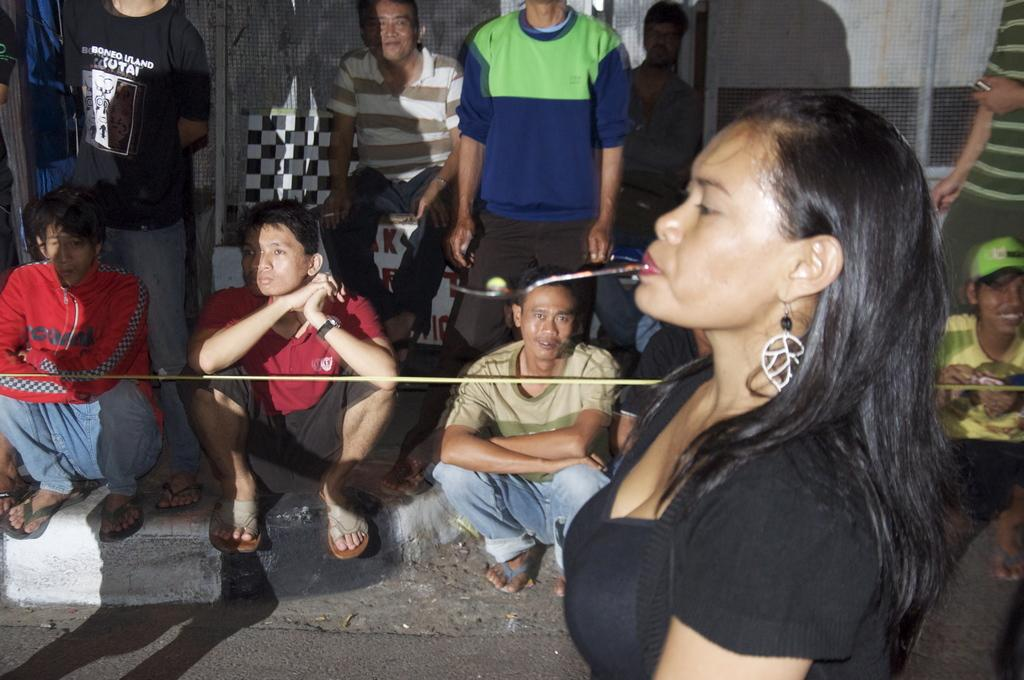What is the main subject of the image? There is a lady in the image. What is the lady doing in the image? The lady is holding something with her mouth. Can you describe the other people in the image? There are people in the image, and some of them are sitting on the floor. What type of substance is the lady using to help the people sitting on the floor? There is no substance mentioned in the image, and the lady is not helping the people sitting on the floor. 